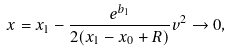<formula> <loc_0><loc_0><loc_500><loc_500>x = x _ { 1 } - \frac { e ^ { b _ { 1 } } } { 2 ( x _ { 1 } - x _ { 0 } + R ) } v ^ { 2 } \to 0 ,</formula> 